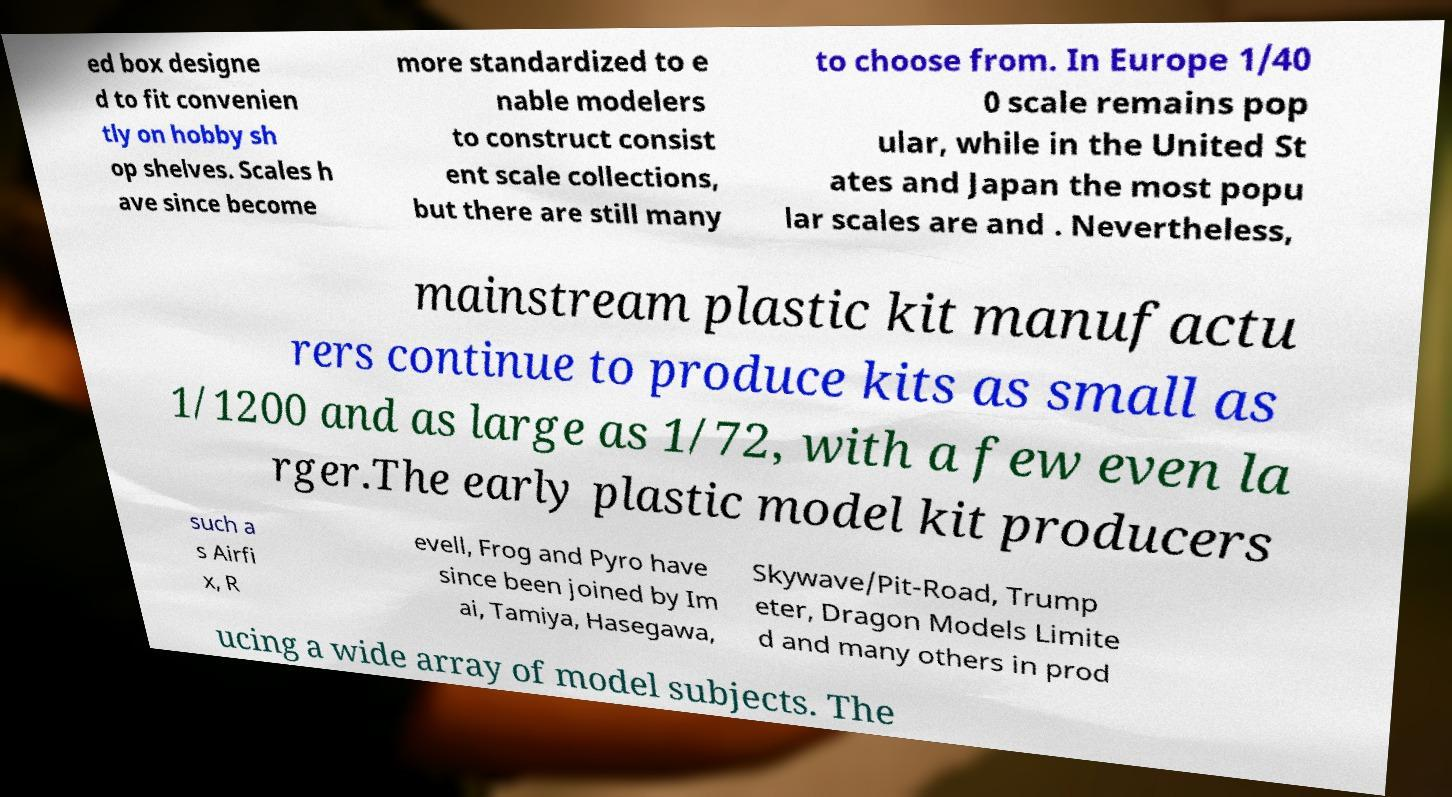I need the written content from this picture converted into text. Can you do that? ed box designe d to fit convenien tly on hobby sh op shelves. Scales h ave since become more standardized to e nable modelers to construct consist ent scale collections, but there are still many to choose from. In Europe 1/40 0 scale remains pop ular, while in the United St ates and Japan the most popu lar scales are and . Nevertheless, mainstream plastic kit manufactu rers continue to produce kits as small as 1/1200 and as large as 1/72, with a few even la rger.The early plastic model kit producers such a s Airfi x, R evell, Frog and Pyro have since been joined by Im ai, Tamiya, Hasegawa, Skywave/Pit-Road, Trump eter, Dragon Models Limite d and many others in prod ucing a wide array of model subjects. The 